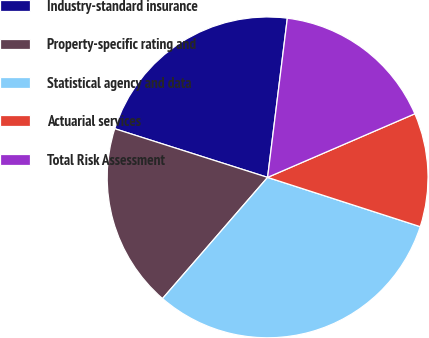<chart> <loc_0><loc_0><loc_500><loc_500><pie_chart><fcel>Industry-standard insurance<fcel>Property-specific rating and<fcel>Statistical agency and data<fcel>Actuarial services<fcel>Total Risk Assessment<nl><fcel>22.06%<fcel>18.54%<fcel>31.4%<fcel>11.46%<fcel>16.55%<nl></chart> 